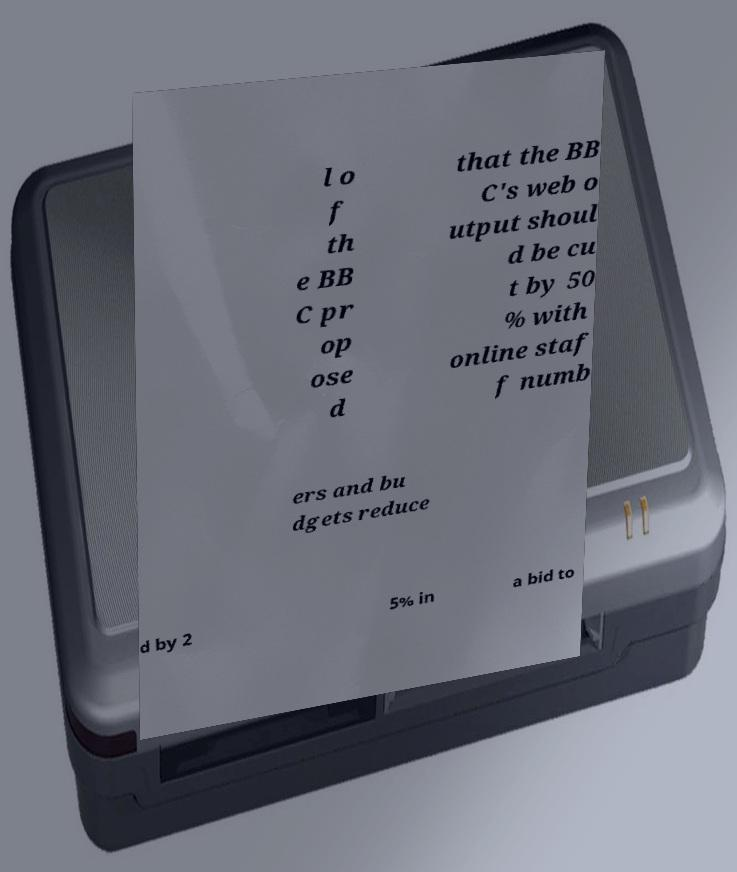Please read and relay the text visible in this image. What does it say? l o f th e BB C pr op ose d that the BB C's web o utput shoul d be cu t by 50 % with online staf f numb ers and bu dgets reduce d by 2 5% in a bid to 